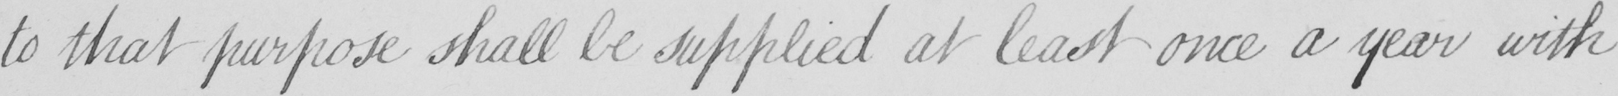Please provide the text content of this handwritten line. to that purpose shall be supplied at least once a year with 